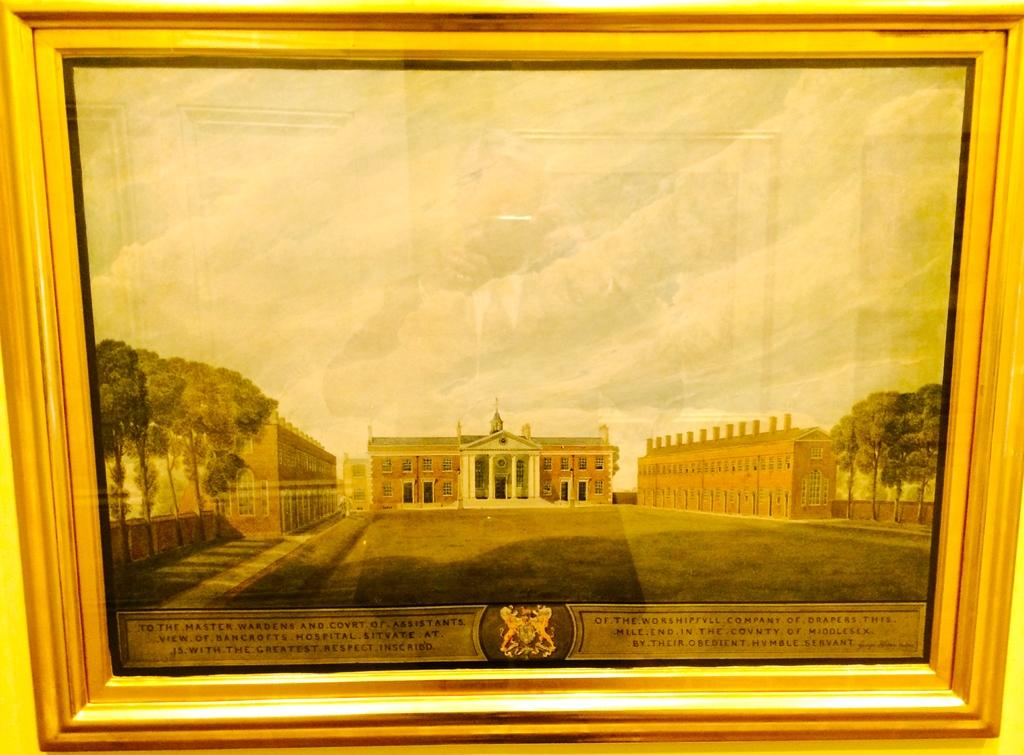What object is present in the image that contains a photo? There is a photo frame in the image. What is depicted in the photo inside the frame? The photo contains buildings and trees. Is there any text present in the photo? Yes, there is text at the bottom of the photo. How does the straw affect the behavior of the fly in the image? There is no straw or fly present in the image. 